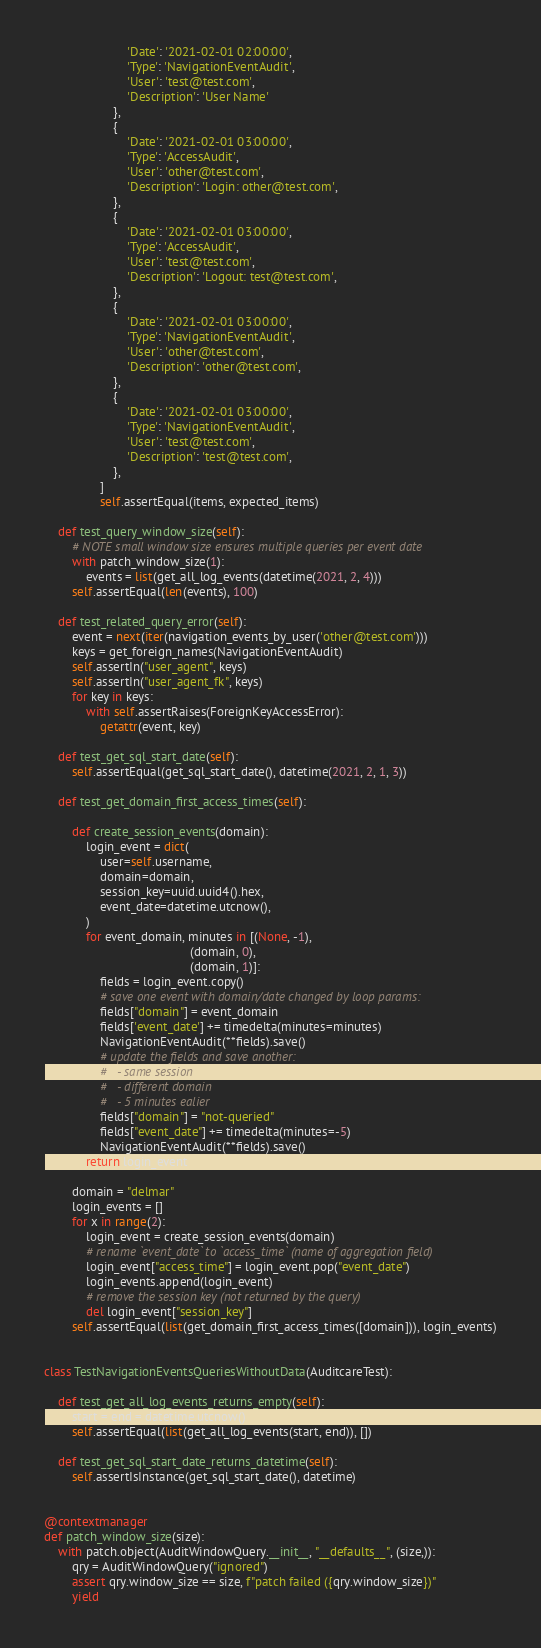<code> <loc_0><loc_0><loc_500><loc_500><_Python_>                        'Date': '2021-02-01 02:00:00',
                        'Type': 'NavigationEventAudit',
                        'User': 'test@test.com',
                        'Description': 'User Name'
                    },
                    {
                        'Date': '2021-02-01 03:00:00',
                        'Type': 'AccessAudit',
                        'User': 'other@test.com',
                        'Description': 'Login: other@test.com',
                    },
                    {
                        'Date': '2021-02-01 03:00:00',
                        'Type': 'AccessAudit',
                        'User': 'test@test.com',
                        'Description': 'Logout: test@test.com',
                    },
                    {
                        'Date': '2021-02-01 03:00:00',
                        'Type': 'NavigationEventAudit',
                        'User': 'other@test.com',
                        'Description': 'other@test.com',
                    },
                    {
                        'Date': '2021-02-01 03:00:00',
                        'Type': 'NavigationEventAudit',
                        'User': 'test@test.com',
                        'Description': 'test@test.com',
                    },
                ]
                self.assertEqual(items, expected_items)

    def test_query_window_size(self):
        # NOTE small window size ensures multiple queries per event date
        with patch_window_size(1):
            events = list(get_all_log_events(datetime(2021, 2, 4)))
        self.assertEqual(len(events), 100)

    def test_related_query_error(self):
        event = next(iter(navigation_events_by_user('other@test.com')))
        keys = get_foreign_names(NavigationEventAudit)
        self.assertIn("user_agent", keys)
        self.assertIn("user_agent_fk", keys)
        for key in keys:
            with self.assertRaises(ForeignKeyAccessError):
                getattr(event, key)

    def test_get_sql_start_date(self):
        self.assertEqual(get_sql_start_date(), datetime(2021, 2, 1, 3))

    def test_get_domain_first_access_times(self):

        def create_session_events(domain):
            login_event = dict(
                user=self.username,
                domain=domain,
                session_key=uuid.uuid4().hex,
                event_date=datetime.utcnow(),
            )
            for event_domain, minutes in [(None, -1),
                                          (domain, 0),
                                          (domain, 1)]:
                fields = login_event.copy()
                # save one event with domain/date changed by loop params:
                fields["domain"] = event_domain
                fields['event_date'] += timedelta(minutes=minutes)
                NavigationEventAudit(**fields).save()
                # update the fields and save another:
                #   - same session
                #   - different domain
                #   - 5 minutes ealier
                fields["domain"] = "not-queried"
                fields["event_date"] += timedelta(minutes=-5)
                NavigationEventAudit(**fields).save()
            return login_event

        domain = "delmar"
        login_events = []
        for x in range(2):
            login_event = create_session_events(domain)
            # rename `event_date` to `access_time` (name of aggregation field)
            login_event["access_time"] = login_event.pop("event_date")
            login_events.append(login_event)
            # remove the session key (not returned by the query)
            del login_event["session_key"]
        self.assertEqual(list(get_domain_first_access_times([domain])), login_events)


class TestNavigationEventsQueriesWithoutData(AuditcareTest):

    def test_get_all_log_events_returns_empty(self):
        start = end = datetime.utcnow()
        self.assertEqual(list(get_all_log_events(start, end)), [])

    def test_get_sql_start_date_returns_datetime(self):
        self.assertIsInstance(get_sql_start_date(), datetime)


@contextmanager
def patch_window_size(size):
    with patch.object(AuditWindowQuery.__init__, "__defaults__", (size,)):
        qry = AuditWindowQuery("ignored")
        assert qry.window_size == size, f"patch failed ({qry.window_size})"
        yield
</code> 